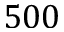<formula> <loc_0><loc_0><loc_500><loc_500>5 0 0</formula> 